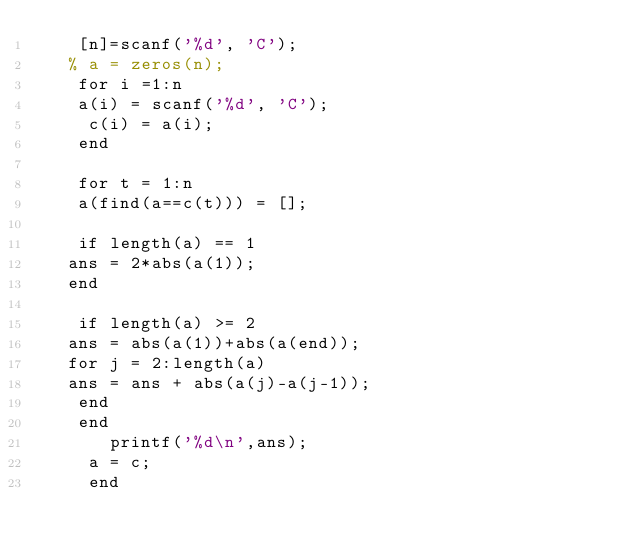Convert code to text. <code><loc_0><loc_0><loc_500><loc_500><_Octave_>    [n]=scanf('%d', 'C');
   % a = zeros(n);
    for i =1:n
    a(i) = scanf('%d', 'C');
     c(i) = a(i);
    end
    
    for t = 1:n
    a(find(a==c(t))) = [];
    
    if length(a) == 1
   ans = 2*abs(a(1));
   end
    
    if length(a) >= 2
   ans = abs(a(1))+abs(a(end));
   for j = 2:length(a)
   ans = ans + abs(a(j)-a(j-1));
    end
    end
       printf('%d\n',ans);
     a = c;
     end</code> 